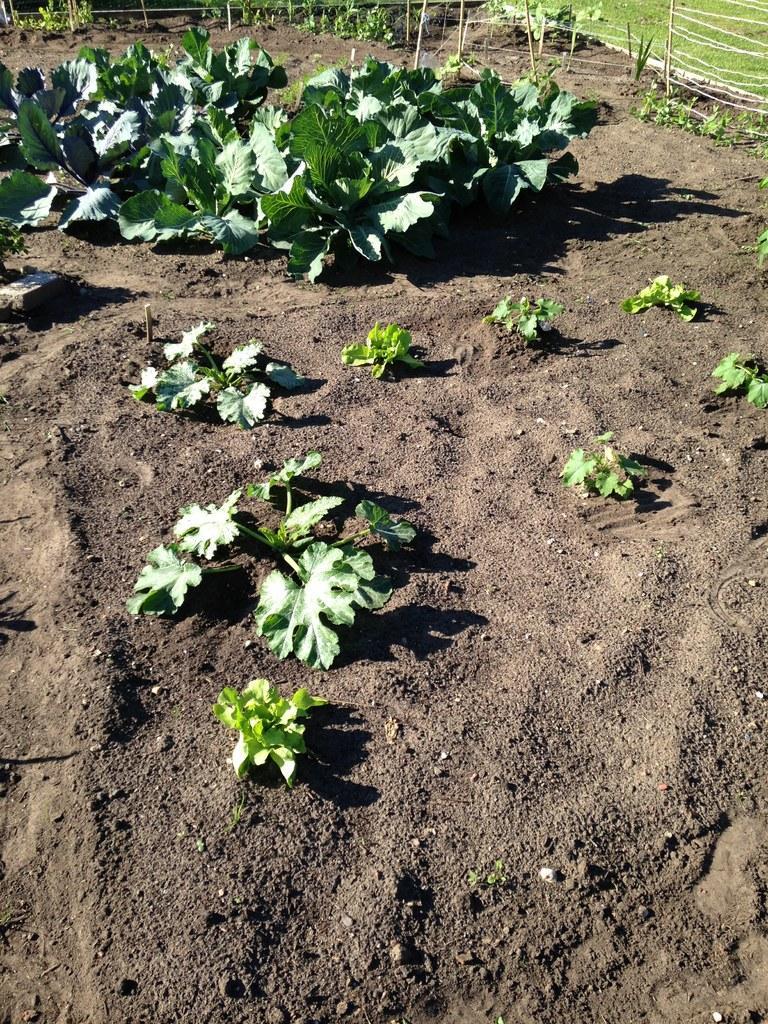Describe this image in one or two sentences. In this image, we can see plants on the ground and in the background, there is a fence. 